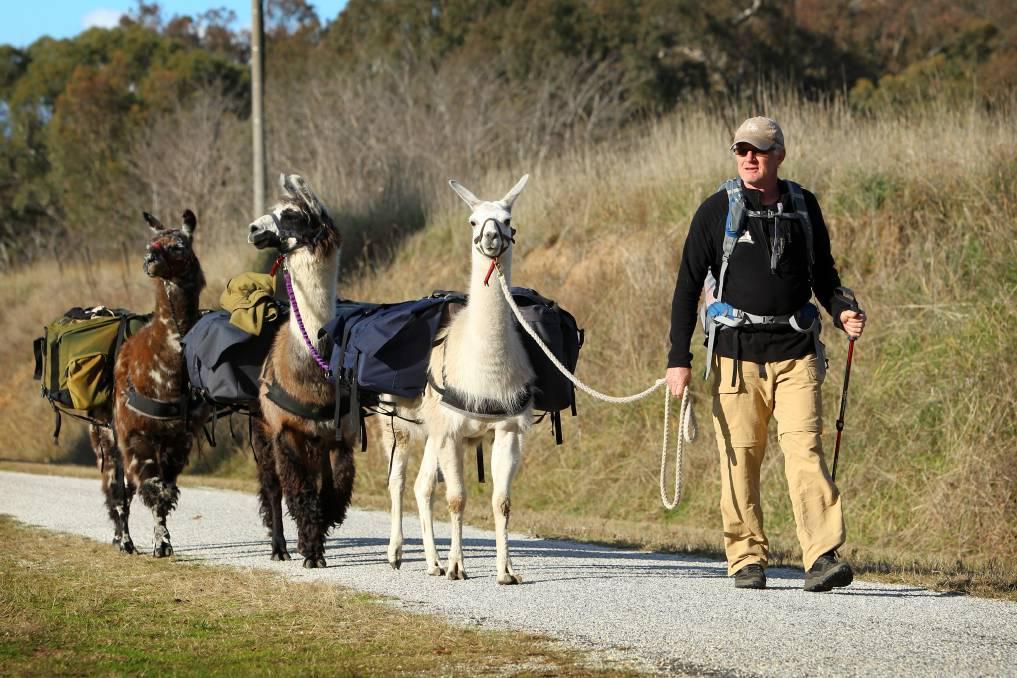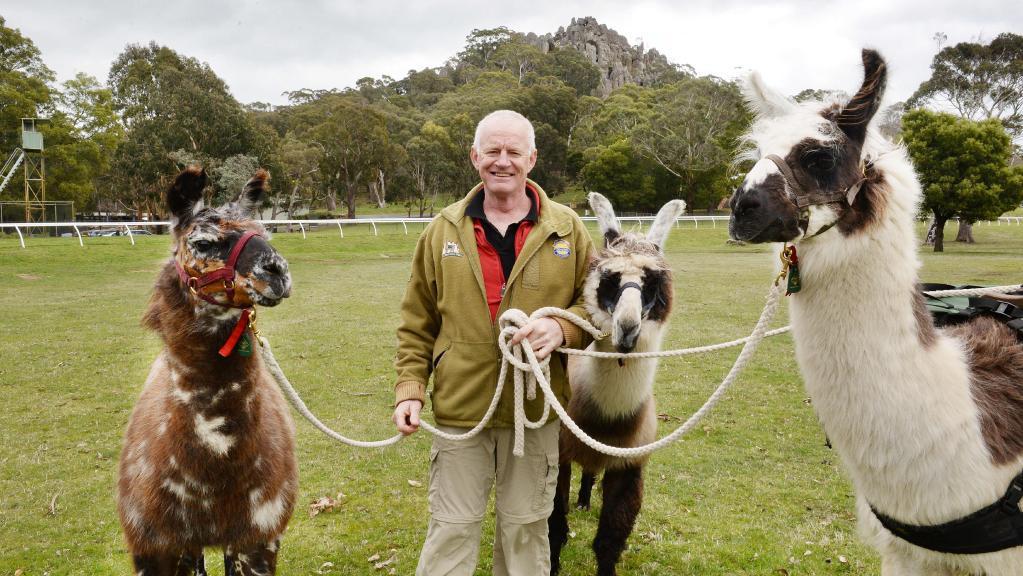The first image is the image on the left, the second image is the image on the right. Examine the images to the left and right. Is the description "There is at least one human in the pair of images." accurate? Answer yes or no. Yes. 